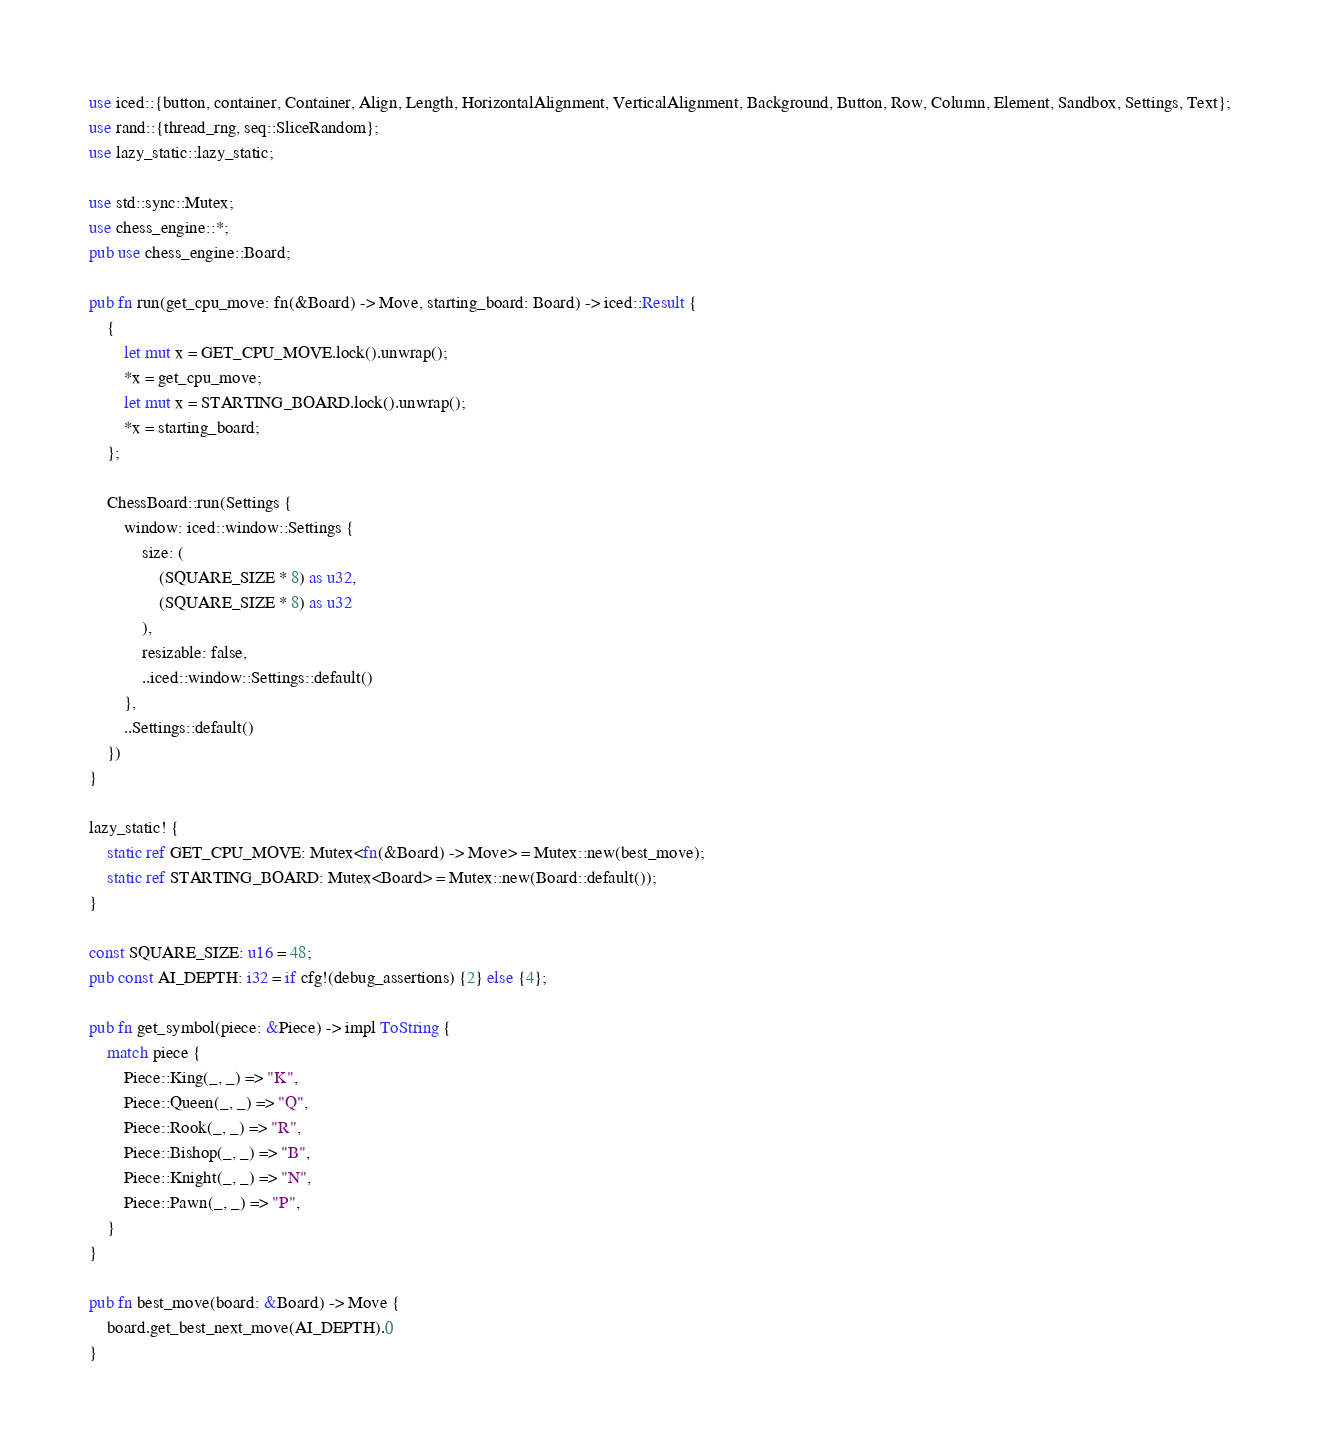<code> <loc_0><loc_0><loc_500><loc_500><_Rust_>use iced::{button, container, Container, Align, Length, HorizontalAlignment, VerticalAlignment, Background, Button, Row, Column, Element, Sandbox, Settings, Text};
use rand::{thread_rng, seq::SliceRandom};
use lazy_static::lazy_static;

use std::sync::Mutex;
use chess_engine::*;
pub use chess_engine::Board;

pub fn run(get_cpu_move: fn(&Board) -> Move, starting_board: Board) -> iced::Result {
    {
        let mut x = GET_CPU_MOVE.lock().unwrap();
        *x = get_cpu_move;
        let mut x = STARTING_BOARD.lock().unwrap();
        *x = starting_board;
    };
    
    ChessBoard::run(Settings {
        window: iced::window::Settings {
            size: (
                (SQUARE_SIZE * 8) as u32,
                (SQUARE_SIZE * 8) as u32
            ),
            resizable: false,
            ..iced::window::Settings::default()
        },
        ..Settings::default()
    })
}

lazy_static! {
    static ref GET_CPU_MOVE: Mutex<fn(&Board) -> Move> = Mutex::new(best_move);
    static ref STARTING_BOARD: Mutex<Board> = Mutex::new(Board::default());
}

const SQUARE_SIZE: u16 = 48;
pub const AI_DEPTH: i32 = if cfg!(debug_assertions) {2} else {4};

pub fn get_symbol(piece: &Piece) -> impl ToString {
	match piece {
		Piece::King(_, _) => "K",
		Piece::Queen(_, _) => "Q",
		Piece::Rook(_, _) => "R",
		Piece::Bishop(_, _) => "B",
		Piece::Knight(_, _) => "N",
		Piece::Pawn(_, _) => "P",
	}
}

pub fn best_move(board: &Board) -> Move {
    board.get_best_next_move(AI_DEPTH).0
}
</code> 